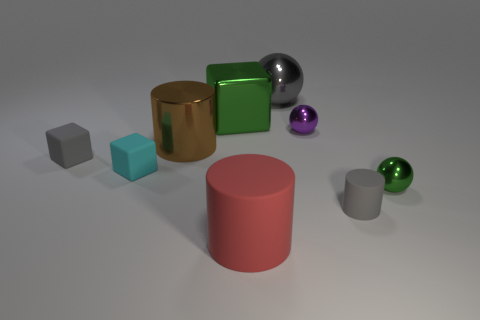Subtract all spheres. How many objects are left? 6 Add 3 small gray spheres. How many small gray spheres exist? 3 Subtract 0 cyan cylinders. How many objects are left? 9 Subtract all matte cubes. Subtract all small cyan things. How many objects are left? 6 Add 2 small gray cubes. How many small gray cubes are left? 3 